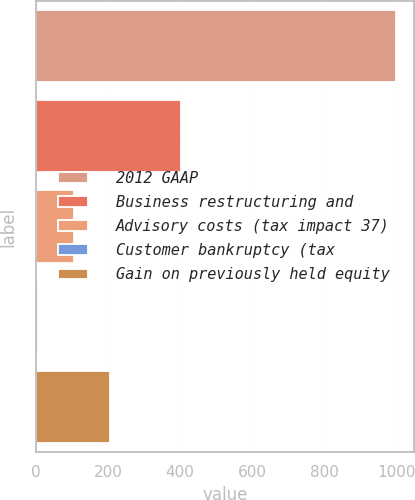Convert chart to OTSL. <chart><loc_0><loc_0><loc_500><loc_500><bar_chart><fcel>2012 GAAP<fcel>Business restructuring and<fcel>Advisory costs (tax impact 37)<fcel>Customer bankruptcy (tax<fcel>Gain on previously held equity<nl><fcel>999.2<fcel>403.34<fcel>105.41<fcel>6.1<fcel>204.72<nl></chart> 